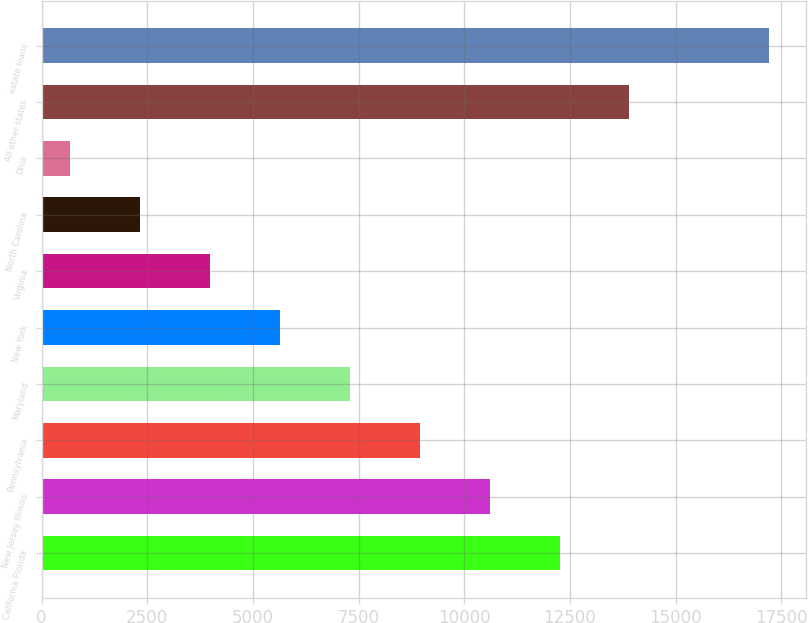Convert chart to OTSL. <chart><loc_0><loc_0><loc_500><loc_500><bar_chart><fcel>California Florida<fcel>New Jersey Illinois<fcel>Pennsylvania<fcel>Maryland<fcel>New York<fcel>Virginia<fcel>North Carolina<fcel>Ohio<fcel>All other states<fcel>estate loans<nl><fcel>12253.6<fcel>10600.8<fcel>8948<fcel>7295.2<fcel>5642.4<fcel>3989.6<fcel>2336.8<fcel>684<fcel>13906.4<fcel>17212<nl></chart> 